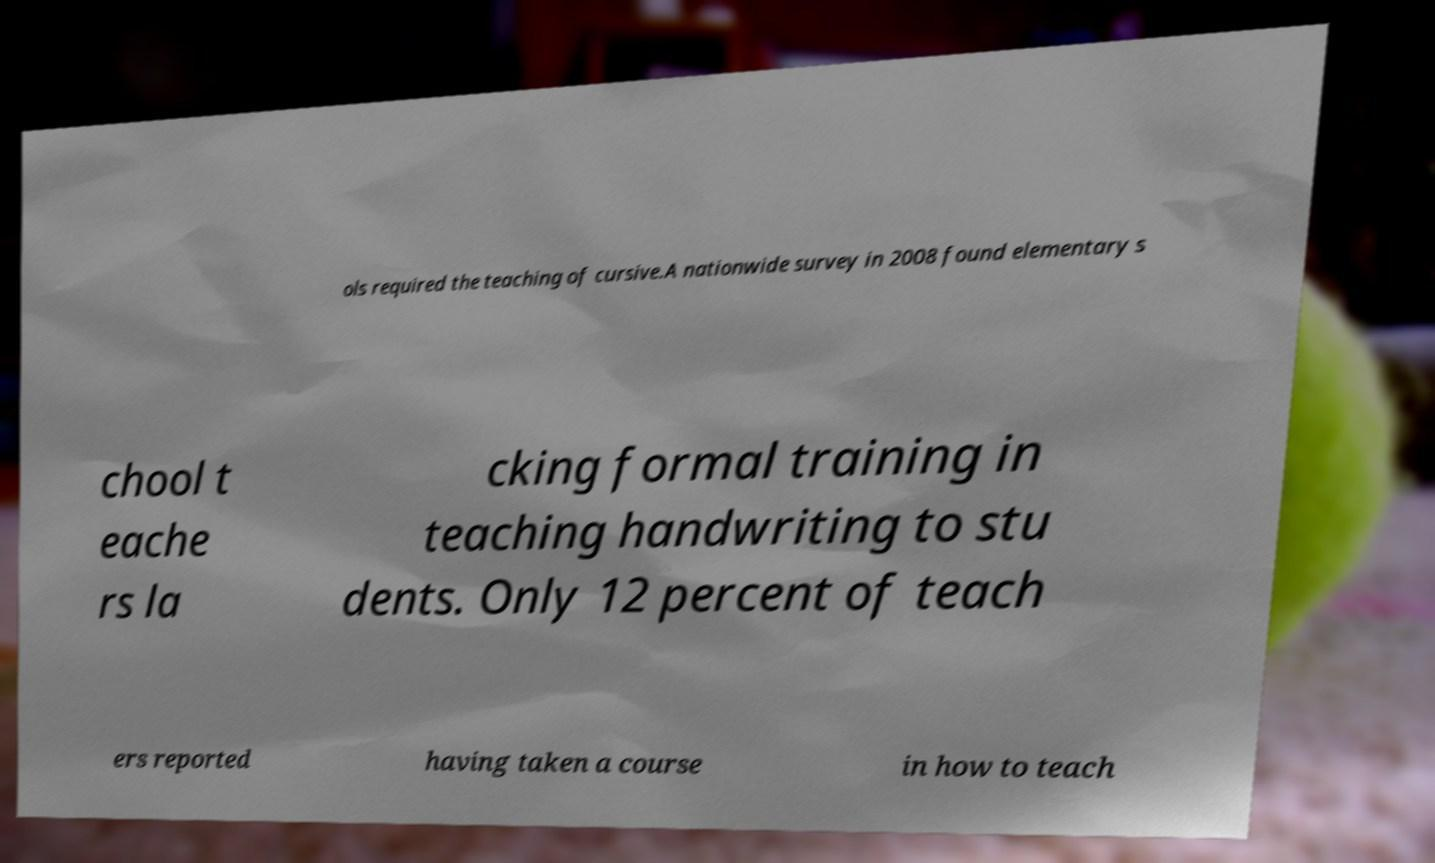Could you extract and type out the text from this image? ols required the teaching of cursive.A nationwide survey in 2008 found elementary s chool t eache rs la cking formal training in teaching handwriting to stu dents. Only 12 percent of teach ers reported having taken a course in how to teach 